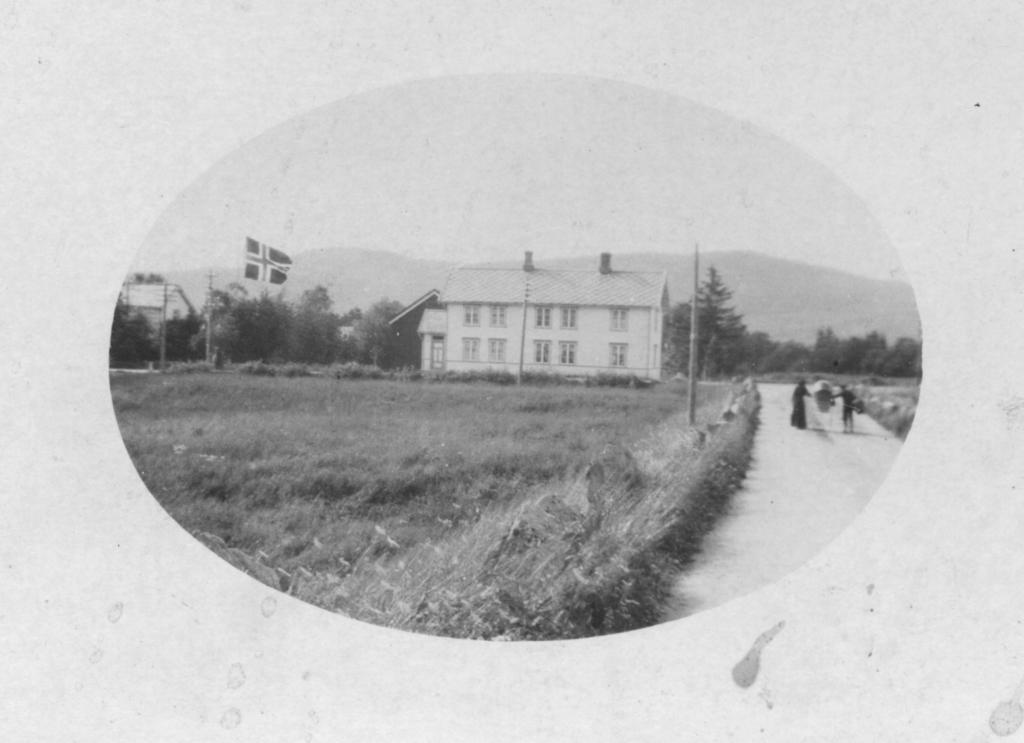What is the color scheme of the image? The image is black and white. What can be seen growing in the image? There is a crop in the image. What type of structure is present in the image? There is a building in the image. What vertical object can be seen in the image? There is a pole in the image. What is the person in the image doing? There is a person walking on the road in the image. What type of natural feature is present in the image? There is a hill in the image. What part of the environment is visible in the image? The sky is visible in the image. Where is the grandmother playing the guitar in the image? There is no grandmother or guitar present in the image. 